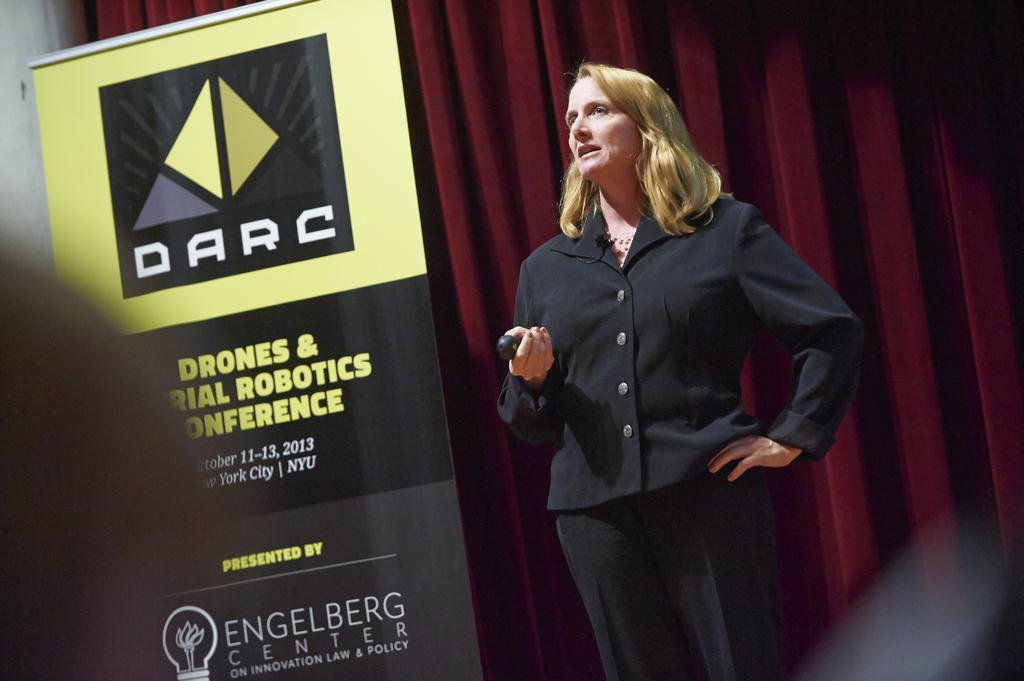What is the woman doing in the image? The woman is standing in the image. What is the woman holding in the image? The woman is holding an object. What can be seen in the image besides the woman? There is a board in the image. What is visible in the background of the image? There is a curtain in the background of the image. How many frogs are jumping on the board in the image? There are no frogs present in the image, and therefore no frogs are jumping on the board. 